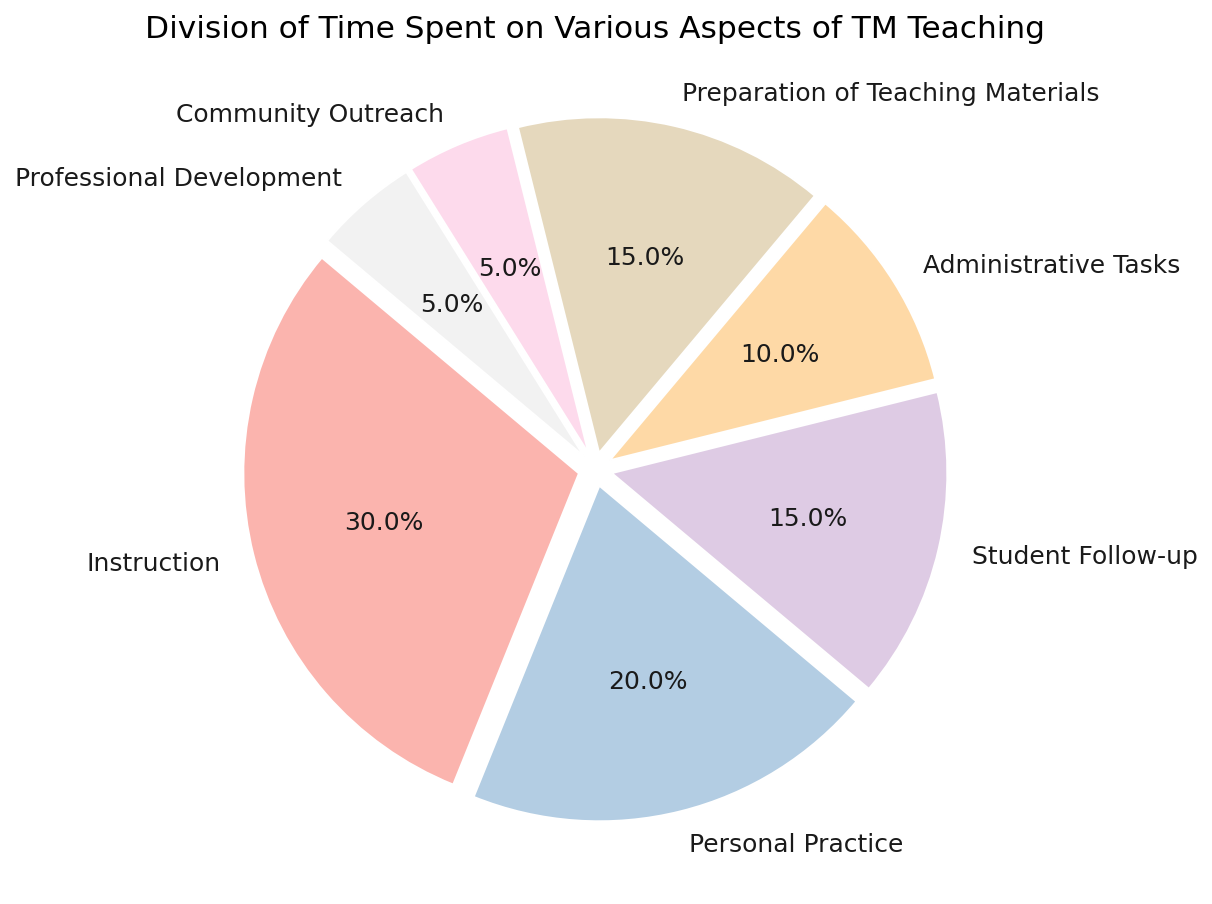What's the total percentage of time spent on Instruction and Administrative Tasks? The percentage of time spent on Instruction is 30%, and for Administrative Tasks, it is 10%. Adding these percentages together gives 30 + 10 = 40%.
Answer: 40% Which activity takes up the largest proportion of time? By examining the pie chart, we see that the largest slice corresponds to "Instruction", which occupies 30% of the total time.
Answer: Instruction How much more time is spent on Personal Practice than on Community Outreach? The pie chart shows that Personal Practice takes up 20% of the time, while Community Outreach takes up 5%. The difference is 20 - 5 = 15%.
Answer: 15% What is the combined percentage of time spent on Student Follow-up, Preparation of Teaching Materials, and Community Outreach? The percentages for Student Follow-up, Preparation of Teaching Materials, and Community Outreach are 15%, 15%, and 5%, respectively. Adding these together gives 15 + 15 + 5 = 35%.
Answer: 35% Which two activities combined account for the same amount of time as Instruction? Instruction takes up 30% of the time. The combined total of Student Follow-up (15%) and Preparation of Teaching Materials (15%) equals 15 + 15 = 30%.
Answer: Student Follow-up and Preparation of Teaching Materials Are Professional Development and Community Outreach given equal time? From the pie chart, both Professional Development and Community Outreach occupy 5% each, so their time allocation is equal.
Answer: Yes What's the least amount of time spent on any single activity? The pie chart shows that the smallest slices, corresponding to Professional Development and Community Outreach, each take up 5% of the time.
Answer: 5% How much more time is spent on Instruction compared to Professional Development? Time spent on Instruction is 30%, while Professional Development is 5%. The difference is 30 - 5 = 25%.
Answer: 25% Which activities together take up exactly half of the time? Combining the time percentages for Instruction (30%) and Personal Practice (20%) sums up to 30 + 20 = 50%, which is half of the total time.
Answer: Instruction and Personal Practice What percentage of time is spent on activities other than Instruction? The total percentage for all activities is 100%. Time spent on Instruction is 30%. The remaining time spent on other activities is 100 - 30 = 70%.
Answer: 70% 